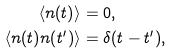Convert formula to latex. <formula><loc_0><loc_0><loc_500><loc_500>\langle n ( t ) \rangle & = 0 , \\ \langle n ( t ) n ( t ^ { \prime } ) \rangle & = \delta ( t - t ^ { \prime } ) ,</formula> 